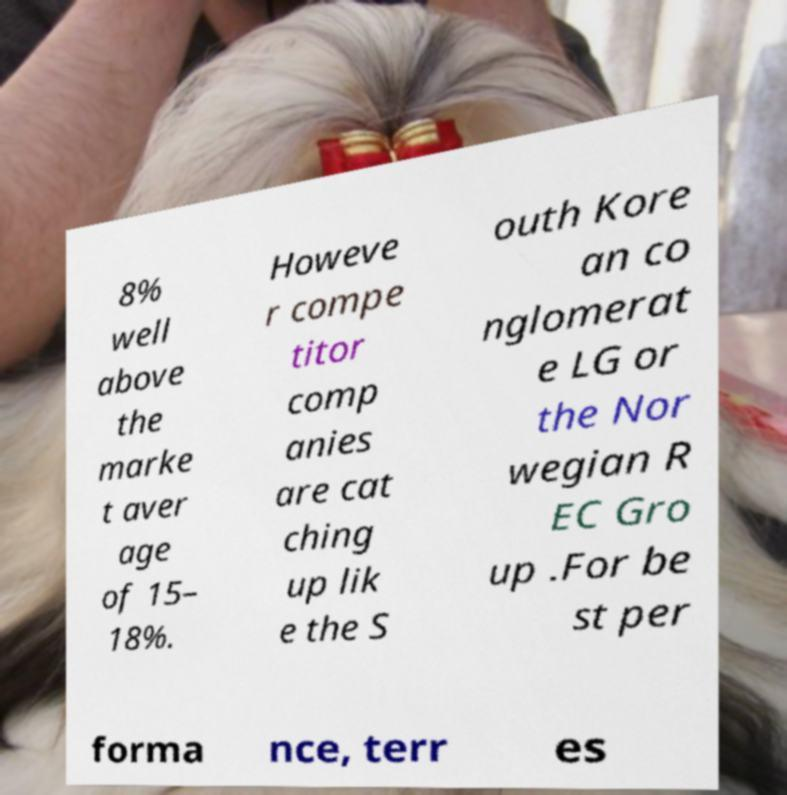Can you accurately transcribe the text from the provided image for me? 8% well above the marke t aver age of 15– 18%. Howeve r compe titor comp anies are cat ching up lik e the S outh Kore an co nglomerat e LG or the Nor wegian R EC Gro up .For be st per forma nce, terr es 